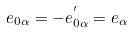Convert formula to latex. <formula><loc_0><loc_0><loc_500><loc_500>e _ { 0 \alpha } = - e ^ { ^ { \prime } } _ { 0 \alpha } = e _ { \alpha }</formula> 